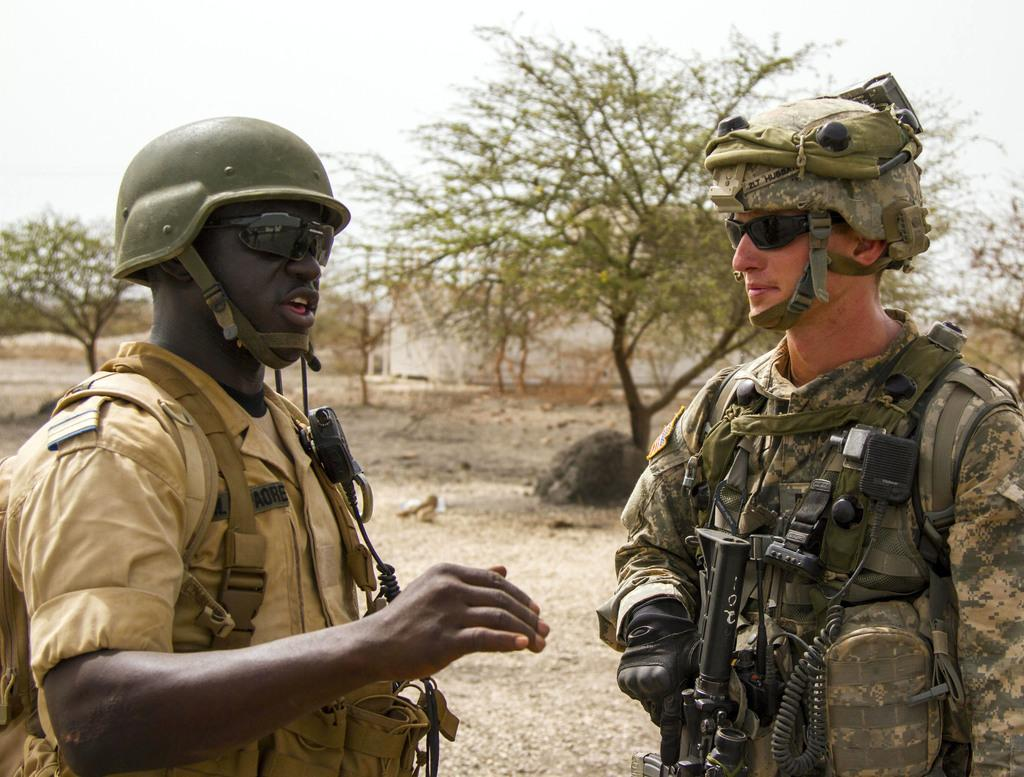What are the two persons in the image wearing? The two persons in the image are wearing uniforms and helmets. What is one person holding in the image? One person is holding a gun in the image. What can be seen in the background of the image? There are trees, a stone, and the sky visible in the background of the image. What type of advertisement can be seen near the stone in the image? There is no advertisement present in the image; it only features two persons with uniforms and helmets, one holding a gun, and the background elements mentioned. 